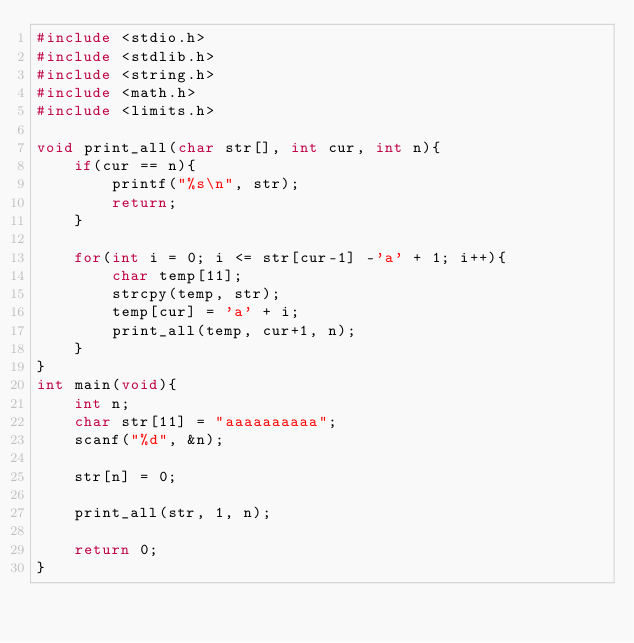<code> <loc_0><loc_0><loc_500><loc_500><_C_>#include <stdio.h>
#include <stdlib.h>
#include <string.h>
#include <math.h>
#include <limits.h>

void print_all(char str[], int cur, int n){
	if(cur == n){
		printf("%s\n", str);
		return;
	}

	for(int i = 0; i <= str[cur-1] -'a' + 1; i++){
		char temp[11];
		strcpy(temp, str);
		temp[cur] = 'a' + i;
		print_all(temp, cur+1, n);
	}
}
int main(void){
	int n;
	char str[11] = "aaaaaaaaaa";
	scanf("%d", &n);

	str[n] = 0;

	print_all(str, 1, n);

	return 0;
}
</code> 